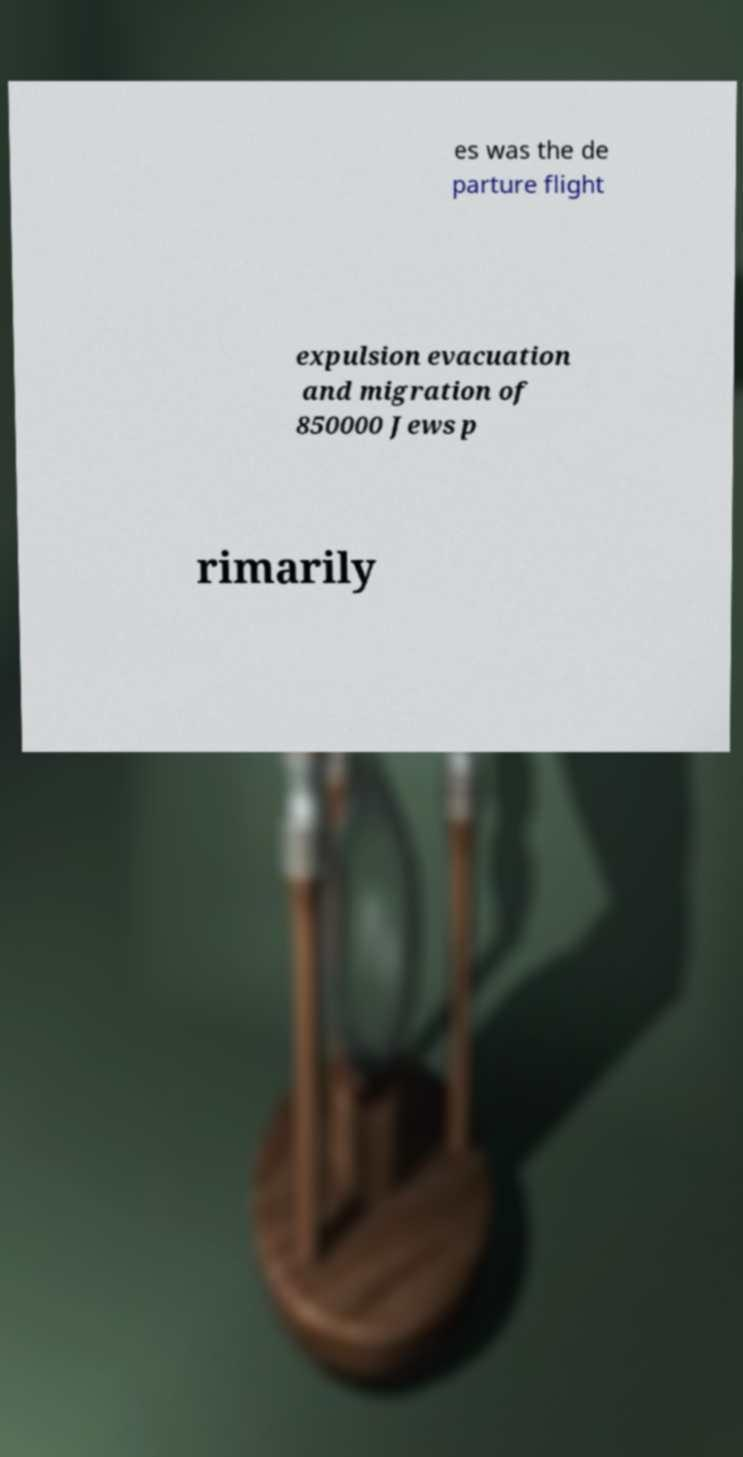Could you assist in decoding the text presented in this image and type it out clearly? es was the de parture flight expulsion evacuation and migration of 850000 Jews p rimarily 